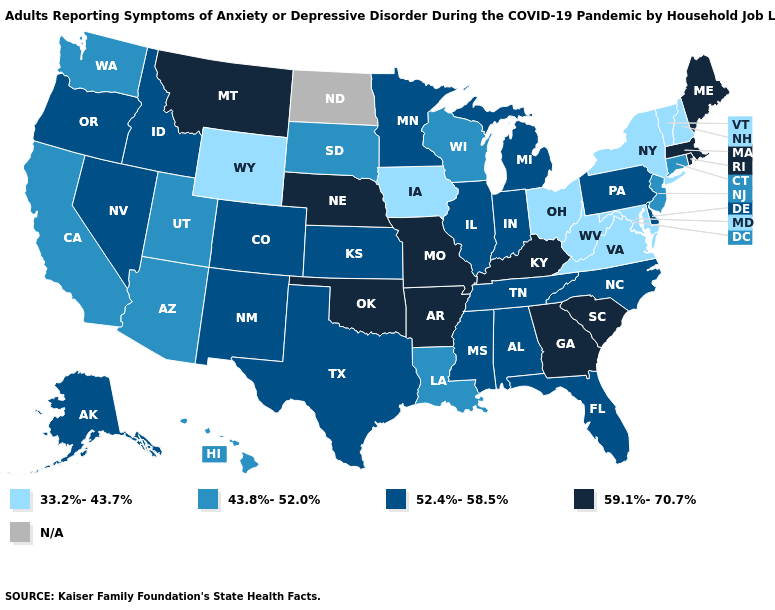What is the value of Florida?
Write a very short answer. 52.4%-58.5%. What is the lowest value in the USA?
Give a very brief answer. 33.2%-43.7%. Does the map have missing data?
Quick response, please. Yes. Does Rhode Island have the highest value in the Northeast?
Concise answer only. Yes. Among the states that border Maryland , does Pennsylvania have the lowest value?
Concise answer only. No. Which states have the lowest value in the USA?
Answer briefly. Iowa, Maryland, New Hampshire, New York, Ohio, Vermont, Virginia, West Virginia, Wyoming. What is the value of Tennessee?
Concise answer only. 52.4%-58.5%. What is the highest value in the USA?
Give a very brief answer. 59.1%-70.7%. What is the lowest value in the Northeast?
Give a very brief answer. 33.2%-43.7%. Which states have the lowest value in the USA?
Write a very short answer. Iowa, Maryland, New Hampshire, New York, Ohio, Vermont, Virginia, West Virginia, Wyoming. What is the lowest value in states that border Connecticut?
Be succinct. 33.2%-43.7%. What is the highest value in the USA?
Quick response, please. 59.1%-70.7%. Name the states that have a value in the range 59.1%-70.7%?
Short answer required. Arkansas, Georgia, Kentucky, Maine, Massachusetts, Missouri, Montana, Nebraska, Oklahoma, Rhode Island, South Carolina. What is the value of Wyoming?
Be succinct. 33.2%-43.7%. What is the value of Alabama?
Be succinct. 52.4%-58.5%. 